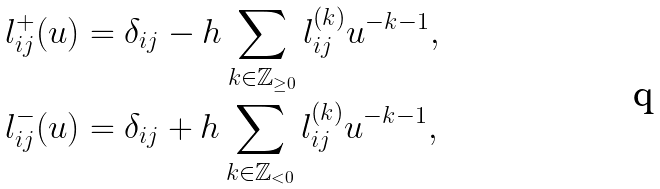Convert formula to latex. <formula><loc_0><loc_0><loc_500><loc_500>l _ { i j } ^ { + } ( u ) & = \delta _ { i j } - h \sum _ { k \in \mathbb { Z } _ { \geq 0 } } l _ { i j } ^ { ( k ) } u ^ { - k - 1 } , \\ l _ { i j } ^ { - } ( u ) & = \delta _ { i j } + h \sum _ { k \in \mathbb { Z } _ { < 0 } } l _ { i j } ^ { ( k ) } u ^ { - k - 1 } ,</formula> 